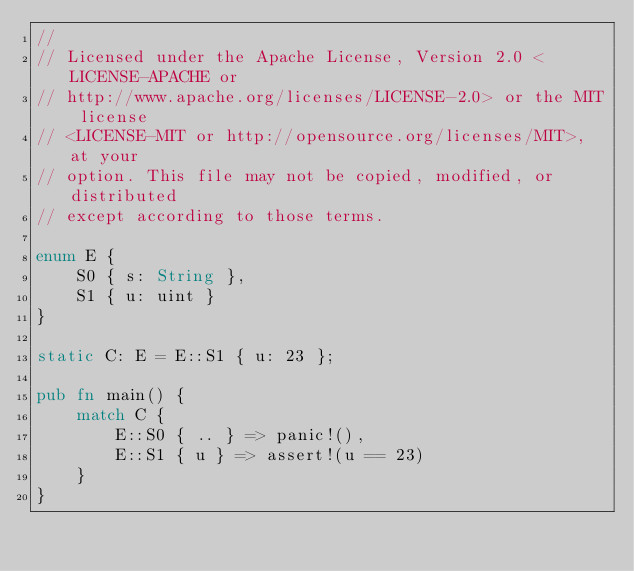<code> <loc_0><loc_0><loc_500><loc_500><_Rust_>//
// Licensed under the Apache License, Version 2.0 <LICENSE-APACHE or
// http://www.apache.org/licenses/LICENSE-2.0> or the MIT license
// <LICENSE-MIT or http://opensource.org/licenses/MIT>, at your
// option. This file may not be copied, modified, or distributed
// except according to those terms.

enum E {
    S0 { s: String },
    S1 { u: uint }
}

static C: E = E::S1 { u: 23 };

pub fn main() {
    match C {
        E::S0 { .. } => panic!(),
        E::S1 { u } => assert!(u == 23)
    }
}
</code> 